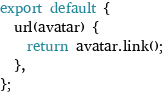Convert code to text. <code><loc_0><loc_0><loc_500><loc_500><_JavaScript_>export default {
  url(avatar) {
    return avatar.link();
  },
};
</code> 